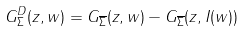Convert formula to latex. <formula><loc_0><loc_0><loc_500><loc_500>G ^ { D } _ { \Sigma } ( z , w ) = G _ { \overline { \Sigma } } ( z , w ) - G _ { \overline { \Sigma } } ( z , I ( w ) )</formula> 